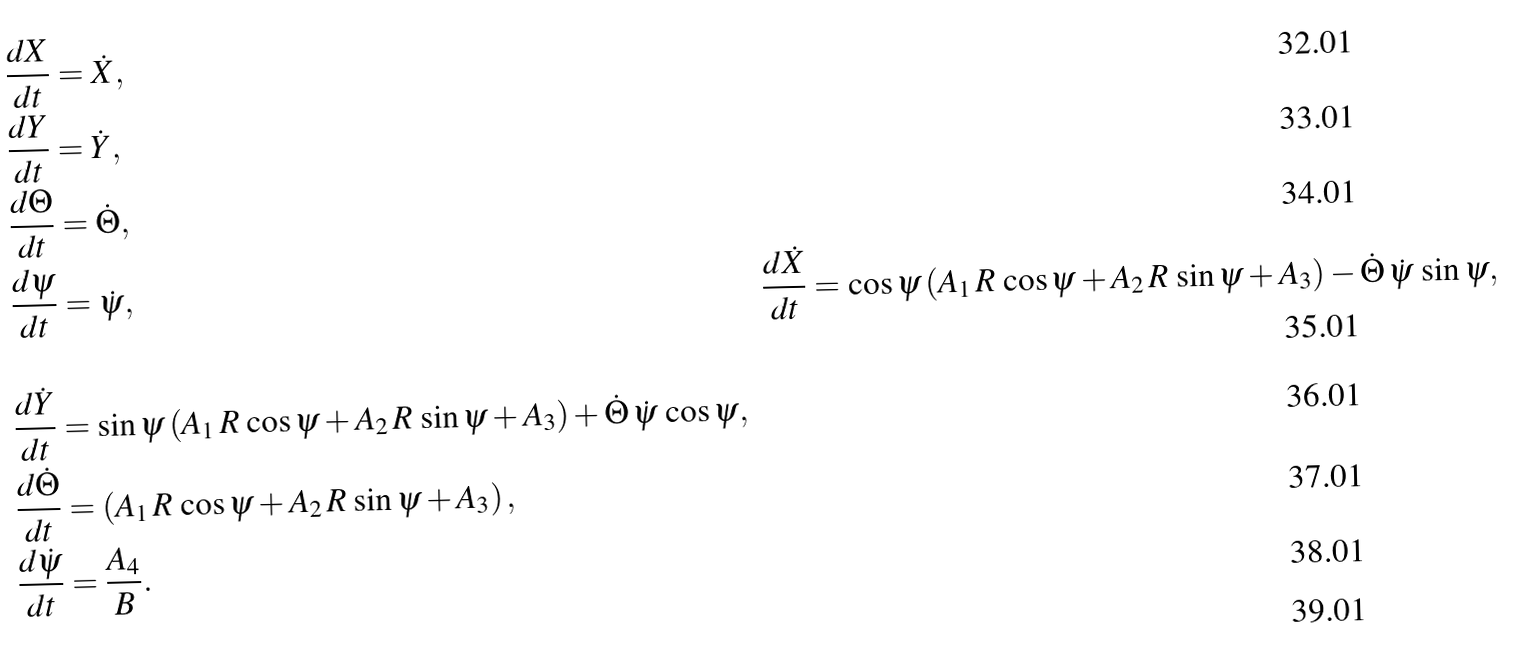Convert formula to latex. <formula><loc_0><loc_0><loc_500><loc_500>& \frac { d X } { d t } = \dot { X } , \\ & \frac { d Y } { d t } = \dot { Y } , \\ & \frac { d \Theta } { d t } = \dot { \Theta } , \\ & \frac { d \psi } { d t } = \dot { \psi } , \quad & \frac { d \dot { X } } { d t } = \cos \psi \left ( A _ { 1 } \, R \, \cos \psi + A _ { 2 } \, R \, \sin \psi + A _ { 3 } \right ) - \dot { \Theta } \, \dot { \psi } \, \sin \psi , \\ & \frac { d \dot { Y } } { d t } = \sin \psi \left ( A _ { 1 } \, R \, \cos \psi + A _ { 2 } \, R \, \sin \psi + A _ { 3 } \right ) + \dot { \Theta } \, \dot { \psi } \, \cos \psi , \\ & \frac { d \dot { \Theta } } { d t } = \left ( A _ { 1 } \, R \, \cos \psi + A _ { 2 } \, R \, \sin \psi + A _ { 3 } \right ) , \\ & \frac { d \dot { \psi } } { d t } = \frac { A _ { 4 } } B . \\</formula> 